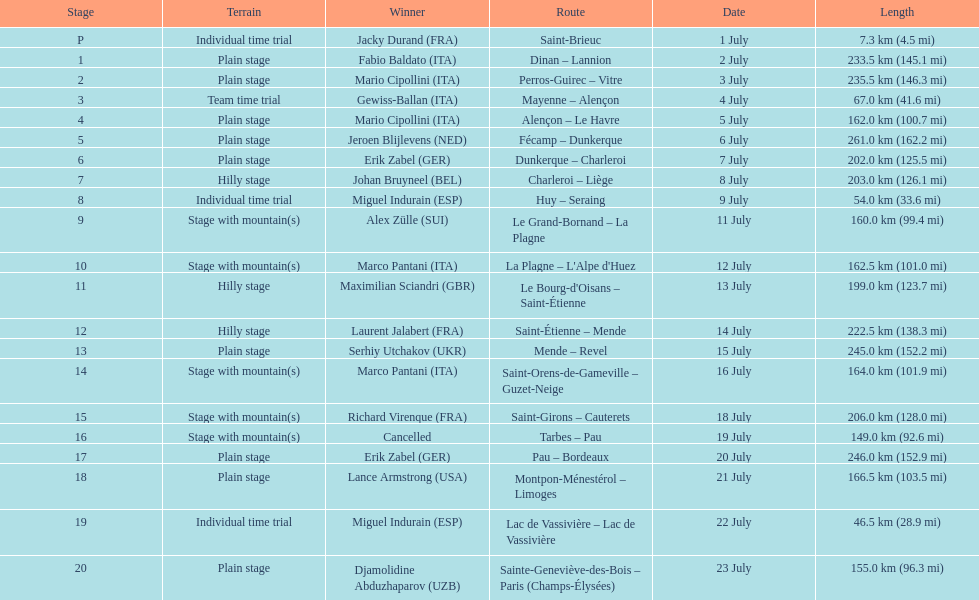Which country had more stage-winners than any other country? Italy. 